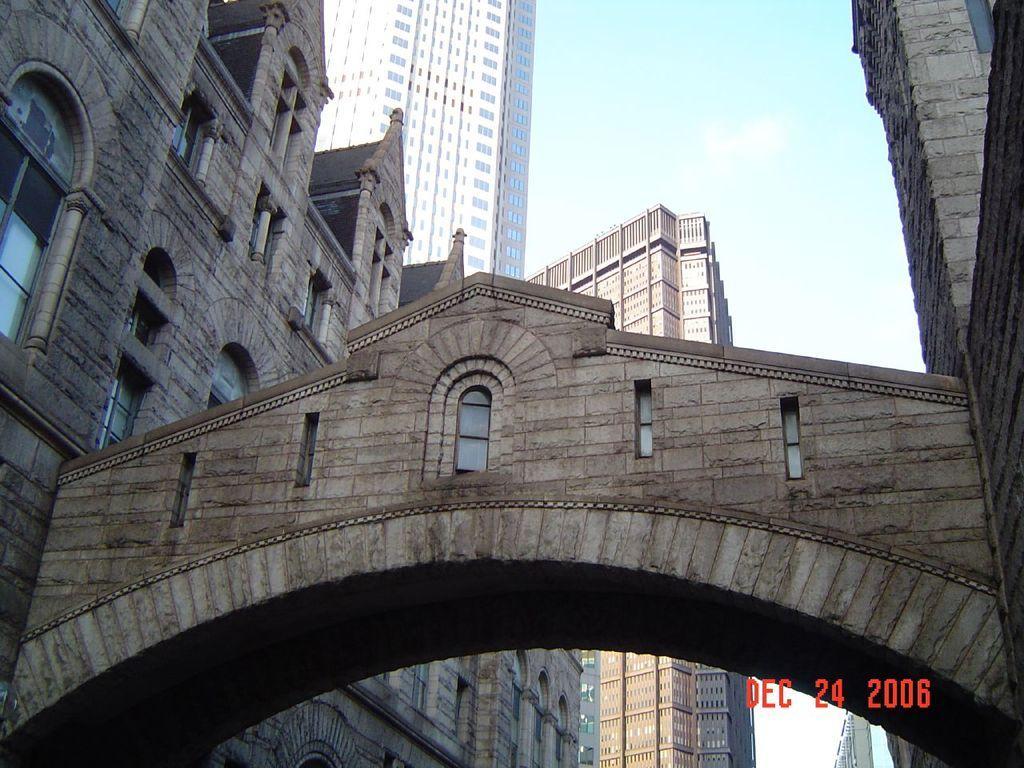Describe this image in one or two sentences. In this picture we can see buildings with windows, arch and in the background we can see the sky with clouds. 